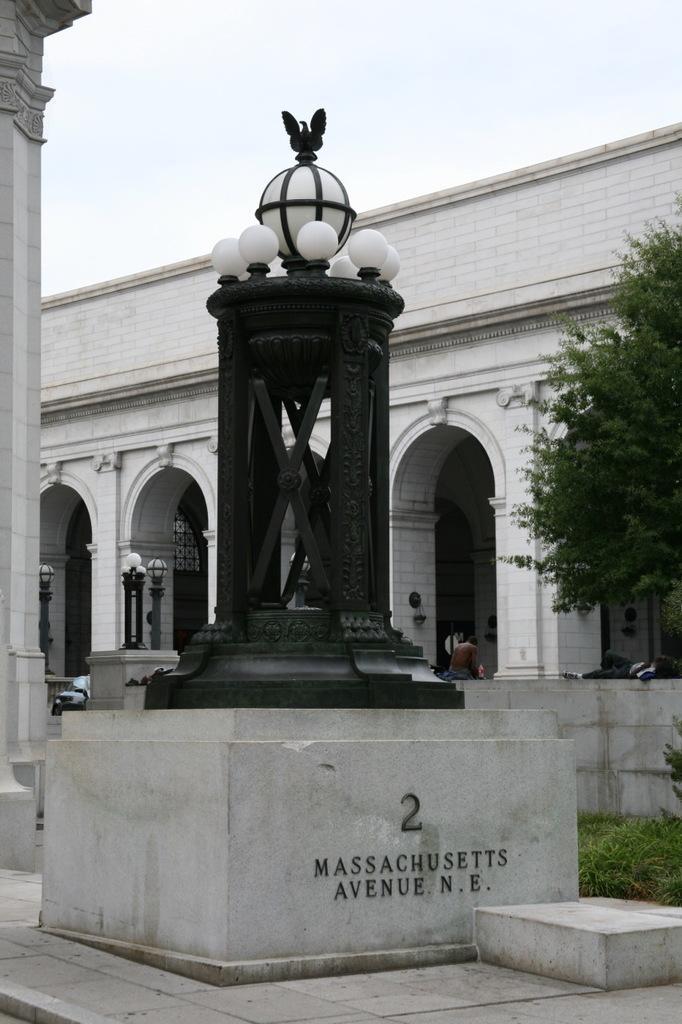In one or two sentences, can you explain what this image depicts? In this image, we can see a few statues. We can see some light poles, pillars. We can see the ground. We can see some grass and a tree. We can see a building and some arches. We can see a person and the sky. 